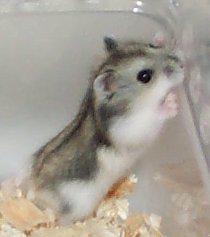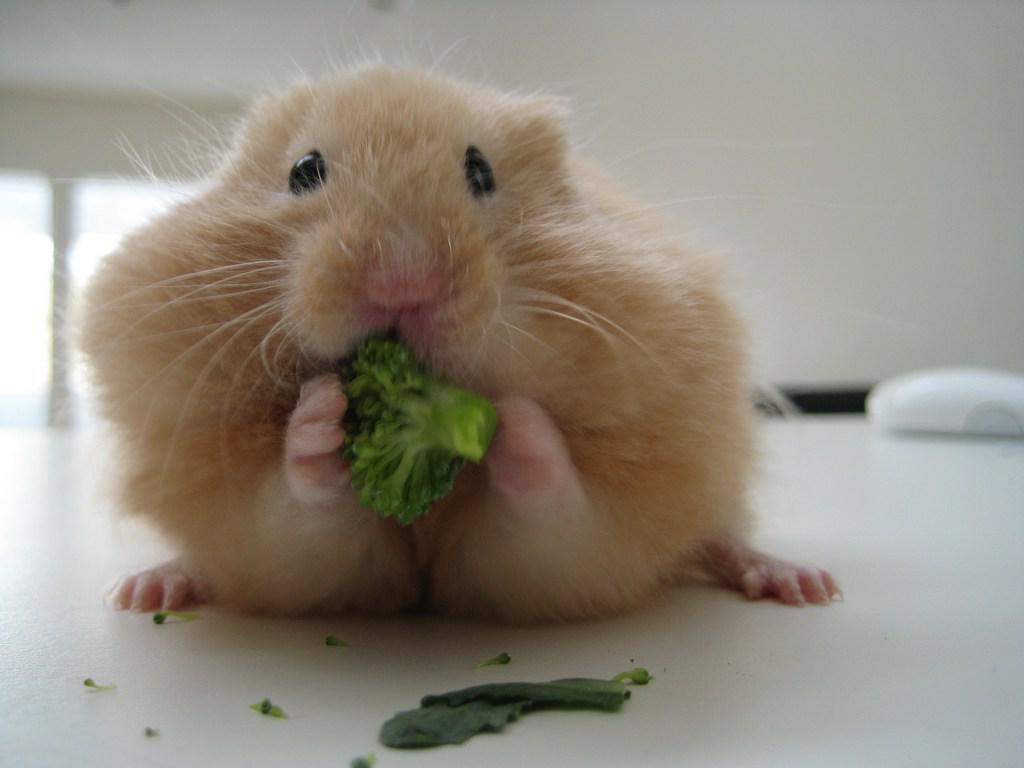The first image is the image on the left, the second image is the image on the right. Analyze the images presented: Is the assertion "In the image to the left, there is a hamster who happens to have at least half of their fur white in color." valid? Answer yes or no. Yes. The first image is the image on the left, the second image is the image on the right. Considering the images on both sides, is "Each image contains one pet rodent, with one on fabric and one on shredded bedding." valid? Answer yes or no. No. 